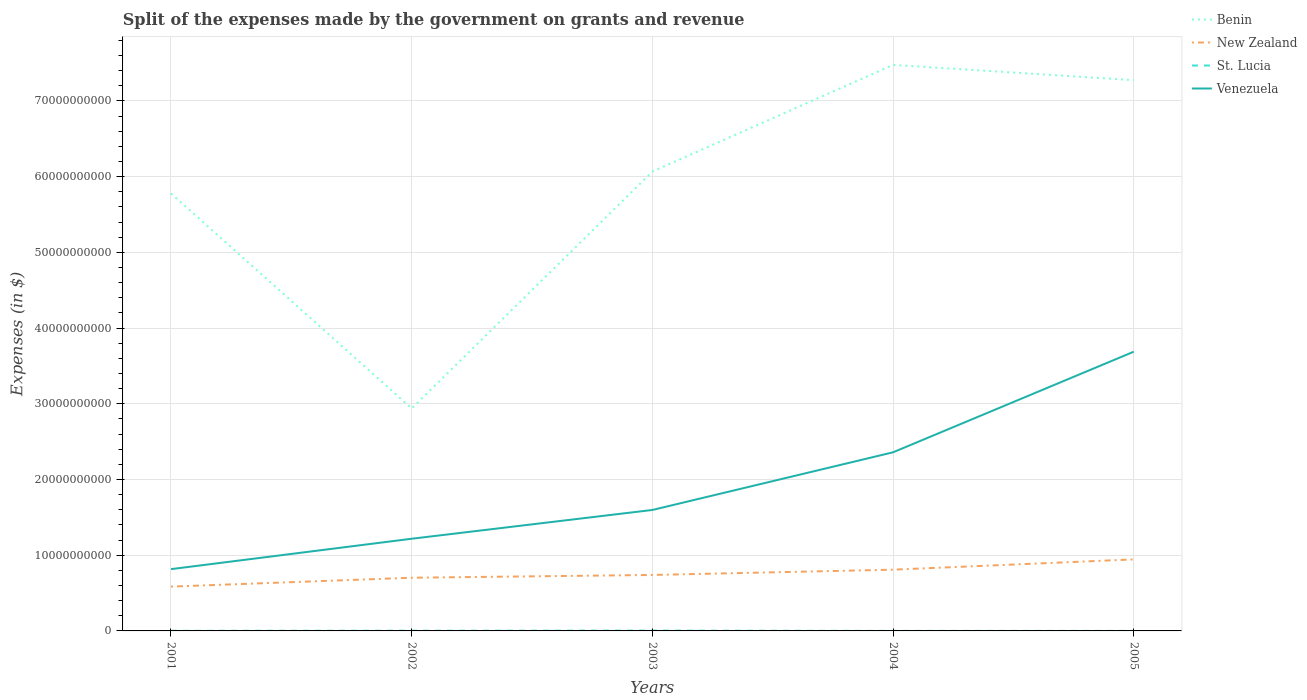How many different coloured lines are there?
Your response must be concise. 4. Does the line corresponding to St. Lucia intersect with the line corresponding to New Zealand?
Give a very brief answer. No. Is the number of lines equal to the number of legend labels?
Your answer should be compact. Yes. Across all years, what is the maximum expenses made by the government on grants and revenue in St. Lucia?
Keep it short and to the point. 4.20e+06. What is the total expenses made by the government on grants and revenue in Benin in the graph?
Provide a short and direct response. -1.21e+1. What is the difference between the highest and the second highest expenses made by the government on grants and revenue in Venezuela?
Your answer should be very brief. 2.87e+1. Is the expenses made by the government on grants and revenue in St. Lucia strictly greater than the expenses made by the government on grants and revenue in Benin over the years?
Keep it short and to the point. Yes. How many lines are there?
Keep it short and to the point. 4. How many years are there in the graph?
Your answer should be very brief. 5. What is the difference between two consecutive major ticks on the Y-axis?
Your answer should be compact. 1.00e+1. Does the graph contain any zero values?
Your answer should be very brief. No. Where does the legend appear in the graph?
Offer a very short reply. Top right. How are the legend labels stacked?
Provide a short and direct response. Vertical. What is the title of the graph?
Your answer should be compact. Split of the expenses made by the government on grants and revenue. What is the label or title of the Y-axis?
Offer a terse response. Expenses (in $). What is the Expenses (in $) of Benin in 2001?
Ensure brevity in your answer.  5.78e+1. What is the Expenses (in $) of New Zealand in 2001?
Your response must be concise. 5.85e+09. What is the Expenses (in $) in St. Lucia in 2001?
Your answer should be very brief. 1.75e+07. What is the Expenses (in $) of Venezuela in 2001?
Ensure brevity in your answer.  8.16e+09. What is the Expenses (in $) in Benin in 2002?
Offer a terse response. 2.94e+1. What is the Expenses (in $) of New Zealand in 2002?
Make the answer very short. 7.03e+09. What is the Expenses (in $) in St. Lucia in 2002?
Offer a terse response. 2.90e+07. What is the Expenses (in $) of Venezuela in 2002?
Make the answer very short. 1.22e+1. What is the Expenses (in $) in Benin in 2003?
Ensure brevity in your answer.  6.07e+1. What is the Expenses (in $) in New Zealand in 2003?
Ensure brevity in your answer.  7.39e+09. What is the Expenses (in $) in St. Lucia in 2003?
Make the answer very short. 4.30e+07. What is the Expenses (in $) of Venezuela in 2003?
Give a very brief answer. 1.60e+1. What is the Expenses (in $) of Benin in 2004?
Make the answer very short. 7.48e+1. What is the Expenses (in $) in New Zealand in 2004?
Your answer should be very brief. 8.09e+09. What is the Expenses (in $) of St. Lucia in 2004?
Make the answer very short. 6.00e+06. What is the Expenses (in $) in Venezuela in 2004?
Make the answer very short. 2.36e+1. What is the Expenses (in $) of Benin in 2005?
Your answer should be very brief. 7.27e+1. What is the Expenses (in $) in New Zealand in 2005?
Keep it short and to the point. 9.45e+09. What is the Expenses (in $) in St. Lucia in 2005?
Offer a terse response. 4.20e+06. What is the Expenses (in $) of Venezuela in 2005?
Provide a short and direct response. 3.69e+1. Across all years, what is the maximum Expenses (in $) in Benin?
Offer a very short reply. 7.48e+1. Across all years, what is the maximum Expenses (in $) of New Zealand?
Offer a terse response. 9.45e+09. Across all years, what is the maximum Expenses (in $) in St. Lucia?
Your answer should be very brief. 4.30e+07. Across all years, what is the maximum Expenses (in $) in Venezuela?
Provide a short and direct response. 3.69e+1. Across all years, what is the minimum Expenses (in $) of Benin?
Make the answer very short. 2.94e+1. Across all years, what is the minimum Expenses (in $) in New Zealand?
Offer a terse response. 5.85e+09. Across all years, what is the minimum Expenses (in $) in St. Lucia?
Provide a short and direct response. 4.20e+06. Across all years, what is the minimum Expenses (in $) in Venezuela?
Keep it short and to the point. 8.16e+09. What is the total Expenses (in $) of Benin in the graph?
Provide a succinct answer. 2.95e+11. What is the total Expenses (in $) of New Zealand in the graph?
Give a very brief answer. 3.78e+1. What is the total Expenses (in $) of St. Lucia in the graph?
Keep it short and to the point. 9.97e+07. What is the total Expenses (in $) of Venezuela in the graph?
Your response must be concise. 9.68e+1. What is the difference between the Expenses (in $) of Benin in 2001 and that in 2002?
Keep it short and to the point. 2.84e+1. What is the difference between the Expenses (in $) of New Zealand in 2001 and that in 2002?
Your answer should be very brief. -1.17e+09. What is the difference between the Expenses (in $) of St. Lucia in 2001 and that in 2002?
Provide a short and direct response. -1.15e+07. What is the difference between the Expenses (in $) of Venezuela in 2001 and that in 2002?
Ensure brevity in your answer.  -4.01e+09. What is the difference between the Expenses (in $) of Benin in 2001 and that in 2003?
Offer a terse response. -2.89e+09. What is the difference between the Expenses (in $) in New Zealand in 2001 and that in 2003?
Your answer should be compact. -1.54e+09. What is the difference between the Expenses (in $) of St. Lucia in 2001 and that in 2003?
Keep it short and to the point. -2.55e+07. What is the difference between the Expenses (in $) of Venezuela in 2001 and that in 2003?
Give a very brief answer. -7.81e+09. What is the difference between the Expenses (in $) in Benin in 2001 and that in 2004?
Your response must be concise. -1.70e+1. What is the difference between the Expenses (in $) in New Zealand in 2001 and that in 2004?
Your response must be concise. -2.23e+09. What is the difference between the Expenses (in $) of St. Lucia in 2001 and that in 2004?
Give a very brief answer. 1.15e+07. What is the difference between the Expenses (in $) in Venezuela in 2001 and that in 2004?
Provide a short and direct response. -1.54e+1. What is the difference between the Expenses (in $) in Benin in 2001 and that in 2005?
Offer a terse response. -1.50e+1. What is the difference between the Expenses (in $) in New Zealand in 2001 and that in 2005?
Keep it short and to the point. -3.59e+09. What is the difference between the Expenses (in $) in St. Lucia in 2001 and that in 2005?
Provide a short and direct response. 1.33e+07. What is the difference between the Expenses (in $) in Venezuela in 2001 and that in 2005?
Your answer should be compact. -2.87e+1. What is the difference between the Expenses (in $) of Benin in 2002 and that in 2003?
Your answer should be compact. -3.13e+1. What is the difference between the Expenses (in $) of New Zealand in 2002 and that in 2003?
Provide a succinct answer. -3.64e+08. What is the difference between the Expenses (in $) of St. Lucia in 2002 and that in 2003?
Offer a terse response. -1.40e+07. What is the difference between the Expenses (in $) of Venezuela in 2002 and that in 2003?
Your answer should be compact. -3.80e+09. What is the difference between the Expenses (in $) in Benin in 2002 and that in 2004?
Ensure brevity in your answer.  -4.54e+1. What is the difference between the Expenses (in $) of New Zealand in 2002 and that in 2004?
Your answer should be compact. -1.06e+09. What is the difference between the Expenses (in $) in St. Lucia in 2002 and that in 2004?
Offer a very short reply. 2.30e+07. What is the difference between the Expenses (in $) in Venezuela in 2002 and that in 2004?
Provide a succinct answer. -1.14e+1. What is the difference between the Expenses (in $) of Benin in 2002 and that in 2005?
Provide a short and direct response. -4.34e+1. What is the difference between the Expenses (in $) in New Zealand in 2002 and that in 2005?
Offer a very short reply. -2.42e+09. What is the difference between the Expenses (in $) of St. Lucia in 2002 and that in 2005?
Ensure brevity in your answer.  2.48e+07. What is the difference between the Expenses (in $) of Venezuela in 2002 and that in 2005?
Your answer should be very brief. -2.47e+1. What is the difference between the Expenses (in $) of Benin in 2003 and that in 2004?
Offer a terse response. -1.41e+1. What is the difference between the Expenses (in $) in New Zealand in 2003 and that in 2004?
Provide a short and direct response. -6.97e+08. What is the difference between the Expenses (in $) of St. Lucia in 2003 and that in 2004?
Your response must be concise. 3.70e+07. What is the difference between the Expenses (in $) of Venezuela in 2003 and that in 2004?
Make the answer very short. -7.62e+09. What is the difference between the Expenses (in $) of Benin in 2003 and that in 2005?
Offer a very short reply. -1.21e+1. What is the difference between the Expenses (in $) in New Zealand in 2003 and that in 2005?
Provide a short and direct response. -2.06e+09. What is the difference between the Expenses (in $) in St. Lucia in 2003 and that in 2005?
Provide a short and direct response. 3.88e+07. What is the difference between the Expenses (in $) of Venezuela in 2003 and that in 2005?
Keep it short and to the point. -2.09e+1. What is the difference between the Expenses (in $) of Benin in 2004 and that in 2005?
Keep it short and to the point. 2.02e+09. What is the difference between the Expenses (in $) in New Zealand in 2004 and that in 2005?
Make the answer very short. -1.36e+09. What is the difference between the Expenses (in $) of St. Lucia in 2004 and that in 2005?
Make the answer very short. 1.80e+06. What is the difference between the Expenses (in $) of Venezuela in 2004 and that in 2005?
Make the answer very short. -1.33e+1. What is the difference between the Expenses (in $) in Benin in 2001 and the Expenses (in $) in New Zealand in 2002?
Your response must be concise. 5.07e+1. What is the difference between the Expenses (in $) of Benin in 2001 and the Expenses (in $) of St. Lucia in 2002?
Provide a short and direct response. 5.77e+1. What is the difference between the Expenses (in $) of Benin in 2001 and the Expenses (in $) of Venezuela in 2002?
Your answer should be very brief. 4.56e+1. What is the difference between the Expenses (in $) in New Zealand in 2001 and the Expenses (in $) in St. Lucia in 2002?
Make the answer very short. 5.82e+09. What is the difference between the Expenses (in $) of New Zealand in 2001 and the Expenses (in $) of Venezuela in 2002?
Make the answer very short. -6.32e+09. What is the difference between the Expenses (in $) of St. Lucia in 2001 and the Expenses (in $) of Venezuela in 2002?
Offer a terse response. -1.22e+1. What is the difference between the Expenses (in $) of Benin in 2001 and the Expenses (in $) of New Zealand in 2003?
Your answer should be very brief. 5.04e+1. What is the difference between the Expenses (in $) of Benin in 2001 and the Expenses (in $) of St. Lucia in 2003?
Ensure brevity in your answer.  5.77e+1. What is the difference between the Expenses (in $) in Benin in 2001 and the Expenses (in $) in Venezuela in 2003?
Your response must be concise. 4.18e+1. What is the difference between the Expenses (in $) in New Zealand in 2001 and the Expenses (in $) in St. Lucia in 2003?
Your answer should be compact. 5.81e+09. What is the difference between the Expenses (in $) of New Zealand in 2001 and the Expenses (in $) of Venezuela in 2003?
Give a very brief answer. -1.01e+1. What is the difference between the Expenses (in $) in St. Lucia in 2001 and the Expenses (in $) in Venezuela in 2003?
Your answer should be compact. -1.60e+1. What is the difference between the Expenses (in $) of Benin in 2001 and the Expenses (in $) of New Zealand in 2004?
Provide a short and direct response. 4.97e+1. What is the difference between the Expenses (in $) in Benin in 2001 and the Expenses (in $) in St. Lucia in 2004?
Provide a short and direct response. 5.78e+1. What is the difference between the Expenses (in $) of Benin in 2001 and the Expenses (in $) of Venezuela in 2004?
Provide a succinct answer. 3.42e+1. What is the difference between the Expenses (in $) of New Zealand in 2001 and the Expenses (in $) of St. Lucia in 2004?
Offer a terse response. 5.85e+09. What is the difference between the Expenses (in $) in New Zealand in 2001 and the Expenses (in $) in Venezuela in 2004?
Offer a terse response. -1.77e+1. What is the difference between the Expenses (in $) in St. Lucia in 2001 and the Expenses (in $) in Venezuela in 2004?
Your response must be concise. -2.36e+1. What is the difference between the Expenses (in $) in Benin in 2001 and the Expenses (in $) in New Zealand in 2005?
Your answer should be compact. 4.83e+1. What is the difference between the Expenses (in $) in Benin in 2001 and the Expenses (in $) in St. Lucia in 2005?
Provide a short and direct response. 5.78e+1. What is the difference between the Expenses (in $) in Benin in 2001 and the Expenses (in $) in Venezuela in 2005?
Offer a very short reply. 2.09e+1. What is the difference between the Expenses (in $) of New Zealand in 2001 and the Expenses (in $) of St. Lucia in 2005?
Your answer should be very brief. 5.85e+09. What is the difference between the Expenses (in $) in New Zealand in 2001 and the Expenses (in $) in Venezuela in 2005?
Make the answer very short. -3.10e+1. What is the difference between the Expenses (in $) of St. Lucia in 2001 and the Expenses (in $) of Venezuela in 2005?
Ensure brevity in your answer.  -3.69e+1. What is the difference between the Expenses (in $) in Benin in 2002 and the Expenses (in $) in New Zealand in 2003?
Keep it short and to the point. 2.20e+1. What is the difference between the Expenses (in $) in Benin in 2002 and the Expenses (in $) in St. Lucia in 2003?
Offer a terse response. 2.93e+1. What is the difference between the Expenses (in $) of Benin in 2002 and the Expenses (in $) of Venezuela in 2003?
Make the answer very short. 1.34e+1. What is the difference between the Expenses (in $) in New Zealand in 2002 and the Expenses (in $) in St. Lucia in 2003?
Make the answer very short. 6.98e+09. What is the difference between the Expenses (in $) in New Zealand in 2002 and the Expenses (in $) in Venezuela in 2003?
Your answer should be compact. -8.95e+09. What is the difference between the Expenses (in $) of St. Lucia in 2002 and the Expenses (in $) of Venezuela in 2003?
Keep it short and to the point. -1.59e+1. What is the difference between the Expenses (in $) of Benin in 2002 and the Expenses (in $) of New Zealand in 2004?
Offer a very short reply. 2.13e+1. What is the difference between the Expenses (in $) in Benin in 2002 and the Expenses (in $) in St. Lucia in 2004?
Your answer should be very brief. 2.94e+1. What is the difference between the Expenses (in $) in Benin in 2002 and the Expenses (in $) in Venezuela in 2004?
Your response must be concise. 5.79e+09. What is the difference between the Expenses (in $) of New Zealand in 2002 and the Expenses (in $) of St. Lucia in 2004?
Give a very brief answer. 7.02e+09. What is the difference between the Expenses (in $) of New Zealand in 2002 and the Expenses (in $) of Venezuela in 2004?
Your answer should be compact. -1.66e+1. What is the difference between the Expenses (in $) of St. Lucia in 2002 and the Expenses (in $) of Venezuela in 2004?
Offer a very short reply. -2.36e+1. What is the difference between the Expenses (in $) of Benin in 2002 and the Expenses (in $) of New Zealand in 2005?
Provide a succinct answer. 1.99e+1. What is the difference between the Expenses (in $) in Benin in 2002 and the Expenses (in $) in St. Lucia in 2005?
Your answer should be compact. 2.94e+1. What is the difference between the Expenses (in $) in Benin in 2002 and the Expenses (in $) in Venezuela in 2005?
Your response must be concise. -7.49e+09. What is the difference between the Expenses (in $) of New Zealand in 2002 and the Expenses (in $) of St. Lucia in 2005?
Make the answer very short. 7.02e+09. What is the difference between the Expenses (in $) in New Zealand in 2002 and the Expenses (in $) in Venezuela in 2005?
Keep it short and to the point. -2.99e+1. What is the difference between the Expenses (in $) in St. Lucia in 2002 and the Expenses (in $) in Venezuela in 2005?
Offer a terse response. -3.68e+1. What is the difference between the Expenses (in $) of Benin in 2003 and the Expenses (in $) of New Zealand in 2004?
Make the answer very short. 5.26e+1. What is the difference between the Expenses (in $) in Benin in 2003 and the Expenses (in $) in St. Lucia in 2004?
Your answer should be compact. 6.07e+1. What is the difference between the Expenses (in $) in Benin in 2003 and the Expenses (in $) in Venezuela in 2004?
Your answer should be very brief. 3.71e+1. What is the difference between the Expenses (in $) in New Zealand in 2003 and the Expenses (in $) in St. Lucia in 2004?
Make the answer very short. 7.38e+09. What is the difference between the Expenses (in $) in New Zealand in 2003 and the Expenses (in $) in Venezuela in 2004?
Your response must be concise. -1.62e+1. What is the difference between the Expenses (in $) in St. Lucia in 2003 and the Expenses (in $) in Venezuela in 2004?
Provide a short and direct response. -2.35e+1. What is the difference between the Expenses (in $) in Benin in 2003 and the Expenses (in $) in New Zealand in 2005?
Your response must be concise. 5.12e+1. What is the difference between the Expenses (in $) in Benin in 2003 and the Expenses (in $) in St. Lucia in 2005?
Your response must be concise. 6.07e+1. What is the difference between the Expenses (in $) of Benin in 2003 and the Expenses (in $) of Venezuela in 2005?
Your answer should be very brief. 2.38e+1. What is the difference between the Expenses (in $) of New Zealand in 2003 and the Expenses (in $) of St. Lucia in 2005?
Your answer should be very brief. 7.39e+09. What is the difference between the Expenses (in $) of New Zealand in 2003 and the Expenses (in $) of Venezuela in 2005?
Provide a short and direct response. -2.95e+1. What is the difference between the Expenses (in $) in St. Lucia in 2003 and the Expenses (in $) in Venezuela in 2005?
Provide a short and direct response. -3.68e+1. What is the difference between the Expenses (in $) in Benin in 2004 and the Expenses (in $) in New Zealand in 2005?
Make the answer very short. 6.53e+1. What is the difference between the Expenses (in $) of Benin in 2004 and the Expenses (in $) of St. Lucia in 2005?
Provide a succinct answer. 7.48e+1. What is the difference between the Expenses (in $) of Benin in 2004 and the Expenses (in $) of Venezuela in 2005?
Give a very brief answer. 3.79e+1. What is the difference between the Expenses (in $) of New Zealand in 2004 and the Expenses (in $) of St. Lucia in 2005?
Make the answer very short. 8.08e+09. What is the difference between the Expenses (in $) in New Zealand in 2004 and the Expenses (in $) in Venezuela in 2005?
Make the answer very short. -2.88e+1. What is the difference between the Expenses (in $) of St. Lucia in 2004 and the Expenses (in $) of Venezuela in 2005?
Provide a short and direct response. -3.69e+1. What is the average Expenses (in $) of Benin per year?
Your answer should be compact. 5.91e+1. What is the average Expenses (in $) of New Zealand per year?
Keep it short and to the point. 7.56e+09. What is the average Expenses (in $) in St. Lucia per year?
Ensure brevity in your answer.  1.99e+07. What is the average Expenses (in $) of Venezuela per year?
Make the answer very short. 1.94e+1. In the year 2001, what is the difference between the Expenses (in $) of Benin and Expenses (in $) of New Zealand?
Offer a terse response. 5.19e+1. In the year 2001, what is the difference between the Expenses (in $) of Benin and Expenses (in $) of St. Lucia?
Provide a short and direct response. 5.78e+1. In the year 2001, what is the difference between the Expenses (in $) of Benin and Expenses (in $) of Venezuela?
Provide a succinct answer. 4.96e+1. In the year 2001, what is the difference between the Expenses (in $) in New Zealand and Expenses (in $) in St. Lucia?
Keep it short and to the point. 5.84e+09. In the year 2001, what is the difference between the Expenses (in $) in New Zealand and Expenses (in $) in Venezuela?
Offer a very short reply. -2.31e+09. In the year 2001, what is the difference between the Expenses (in $) of St. Lucia and Expenses (in $) of Venezuela?
Ensure brevity in your answer.  -8.14e+09. In the year 2002, what is the difference between the Expenses (in $) of Benin and Expenses (in $) of New Zealand?
Offer a very short reply. 2.24e+1. In the year 2002, what is the difference between the Expenses (in $) of Benin and Expenses (in $) of St. Lucia?
Your answer should be compact. 2.94e+1. In the year 2002, what is the difference between the Expenses (in $) of Benin and Expenses (in $) of Venezuela?
Your answer should be compact. 1.72e+1. In the year 2002, what is the difference between the Expenses (in $) in New Zealand and Expenses (in $) in St. Lucia?
Provide a succinct answer. 7.00e+09. In the year 2002, what is the difference between the Expenses (in $) of New Zealand and Expenses (in $) of Venezuela?
Provide a succinct answer. -5.15e+09. In the year 2002, what is the difference between the Expenses (in $) of St. Lucia and Expenses (in $) of Venezuela?
Your answer should be compact. -1.21e+1. In the year 2003, what is the difference between the Expenses (in $) of Benin and Expenses (in $) of New Zealand?
Your answer should be compact. 5.33e+1. In the year 2003, what is the difference between the Expenses (in $) of Benin and Expenses (in $) of St. Lucia?
Give a very brief answer. 6.06e+1. In the year 2003, what is the difference between the Expenses (in $) in Benin and Expenses (in $) in Venezuela?
Make the answer very short. 4.47e+1. In the year 2003, what is the difference between the Expenses (in $) in New Zealand and Expenses (in $) in St. Lucia?
Give a very brief answer. 7.35e+09. In the year 2003, what is the difference between the Expenses (in $) in New Zealand and Expenses (in $) in Venezuela?
Your answer should be compact. -8.58e+09. In the year 2003, what is the difference between the Expenses (in $) of St. Lucia and Expenses (in $) of Venezuela?
Provide a short and direct response. -1.59e+1. In the year 2004, what is the difference between the Expenses (in $) in Benin and Expenses (in $) in New Zealand?
Make the answer very short. 6.67e+1. In the year 2004, what is the difference between the Expenses (in $) in Benin and Expenses (in $) in St. Lucia?
Your response must be concise. 7.47e+1. In the year 2004, what is the difference between the Expenses (in $) of Benin and Expenses (in $) of Venezuela?
Provide a succinct answer. 5.12e+1. In the year 2004, what is the difference between the Expenses (in $) of New Zealand and Expenses (in $) of St. Lucia?
Your answer should be very brief. 8.08e+09. In the year 2004, what is the difference between the Expenses (in $) in New Zealand and Expenses (in $) in Venezuela?
Ensure brevity in your answer.  -1.55e+1. In the year 2004, what is the difference between the Expenses (in $) of St. Lucia and Expenses (in $) of Venezuela?
Make the answer very short. -2.36e+1. In the year 2005, what is the difference between the Expenses (in $) in Benin and Expenses (in $) in New Zealand?
Provide a short and direct response. 6.33e+1. In the year 2005, what is the difference between the Expenses (in $) of Benin and Expenses (in $) of St. Lucia?
Give a very brief answer. 7.27e+1. In the year 2005, what is the difference between the Expenses (in $) in Benin and Expenses (in $) in Venezuela?
Give a very brief answer. 3.59e+1. In the year 2005, what is the difference between the Expenses (in $) of New Zealand and Expenses (in $) of St. Lucia?
Make the answer very short. 9.44e+09. In the year 2005, what is the difference between the Expenses (in $) in New Zealand and Expenses (in $) in Venezuela?
Your answer should be very brief. -2.74e+1. In the year 2005, what is the difference between the Expenses (in $) of St. Lucia and Expenses (in $) of Venezuela?
Your answer should be very brief. -3.69e+1. What is the ratio of the Expenses (in $) in Benin in 2001 to that in 2002?
Make the answer very short. 1.97. What is the ratio of the Expenses (in $) of New Zealand in 2001 to that in 2002?
Your answer should be very brief. 0.83. What is the ratio of the Expenses (in $) in St. Lucia in 2001 to that in 2002?
Your answer should be compact. 0.6. What is the ratio of the Expenses (in $) of Venezuela in 2001 to that in 2002?
Your answer should be compact. 0.67. What is the ratio of the Expenses (in $) in Benin in 2001 to that in 2003?
Your answer should be compact. 0.95. What is the ratio of the Expenses (in $) of New Zealand in 2001 to that in 2003?
Give a very brief answer. 0.79. What is the ratio of the Expenses (in $) in St. Lucia in 2001 to that in 2003?
Offer a very short reply. 0.41. What is the ratio of the Expenses (in $) in Venezuela in 2001 to that in 2003?
Provide a succinct answer. 0.51. What is the ratio of the Expenses (in $) of Benin in 2001 to that in 2004?
Your answer should be compact. 0.77. What is the ratio of the Expenses (in $) of New Zealand in 2001 to that in 2004?
Provide a short and direct response. 0.72. What is the ratio of the Expenses (in $) in St. Lucia in 2001 to that in 2004?
Make the answer very short. 2.92. What is the ratio of the Expenses (in $) of Venezuela in 2001 to that in 2004?
Keep it short and to the point. 0.35. What is the ratio of the Expenses (in $) in Benin in 2001 to that in 2005?
Give a very brief answer. 0.79. What is the ratio of the Expenses (in $) of New Zealand in 2001 to that in 2005?
Make the answer very short. 0.62. What is the ratio of the Expenses (in $) in St. Lucia in 2001 to that in 2005?
Offer a very short reply. 4.17. What is the ratio of the Expenses (in $) in Venezuela in 2001 to that in 2005?
Your answer should be very brief. 0.22. What is the ratio of the Expenses (in $) in Benin in 2002 to that in 2003?
Offer a very short reply. 0.48. What is the ratio of the Expenses (in $) in New Zealand in 2002 to that in 2003?
Keep it short and to the point. 0.95. What is the ratio of the Expenses (in $) in St. Lucia in 2002 to that in 2003?
Your answer should be very brief. 0.67. What is the ratio of the Expenses (in $) in Venezuela in 2002 to that in 2003?
Ensure brevity in your answer.  0.76. What is the ratio of the Expenses (in $) in Benin in 2002 to that in 2004?
Keep it short and to the point. 0.39. What is the ratio of the Expenses (in $) of New Zealand in 2002 to that in 2004?
Offer a terse response. 0.87. What is the ratio of the Expenses (in $) in St. Lucia in 2002 to that in 2004?
Keep it short and to the point. 4.83. What is the ratio of the Expenses (in $) in Venezuela in 2002 to that in 2004?
Make the answer very short. 0.52. What is the ratio of the Expenses (in $) in Benin in 2002 to that in 2005?
Ensure brevity in your answer.  0.4. What is the ratio of the Expenses (in $) in New Zealand in 2002 to that in 2005?
Provide a short and direct response. 0.74. What is the ratio of the Expenses (in $) in St. Lucia in 2002 to that in 2005?
Keep it short and to the point. 6.9. What is the ratio of the Expenses (in $) in Venezuela in 2002 to that in 2005?
Your response must be concise. 0.33. What is the ratio of the Expenses (in $) in Benin in 2003 to that in 2004?
Offer a very short reply. 0.81. What is the ratio of the Expenses (in $) of New Zealand in 2003 to that in 2004?
Give a very brief answer. 0.91. What is the ratio of the Expenses (in $) in St. Lucia in 2003 to that in 2004?
Offer a terse response. 7.17. What is the ratio of the Expenses (in $) of Venezuela in 2003 to that in 2004?
Give a very brief answer. 0.68. What is the ratio of the Expenses (in $) of Benin in 2003 to that in 2005?
Provide a succinct answer. 0.83. What is the ratio of the Expenses (in $) of New Zealand in 2003 to that in 2005?
Make the answer very short. 0.78. What is the ratio of the Expenses (in $) in St. Lucia in 2003 to that in 2005?
Your response must be concise. 10.24. What is the ratio of the Expenses (in $) in Venezuela in 2003 to that in 2005?
Make the answer very short. 0.43. What is the ratio of the Expenses (in $) in Benin in 2004 to that in 2005?
Make the answer very short. 1.03. What is the ratio of the Expenses (in $) of New Zealand in 2004 to that in 2005?
Offer a very short reply. 0.86. What is the ratio of the Expenses (in $) of St. Lucia in 2004 to that in 2005?
Make the answer very short. 1.43. What is the ratio of the Expenses (in $) of Venezuela in 2004 to that in 2005?
Ensure brevity in your answer.  0.64. What is the difference between the highest and the second highest Expenses (in $) of Benin?
Your response must be concise. 2.02e+09. What is the difference between the highest and the second highest Expenses (in $) in New Zealand?
Keep it short and to the point. 1.36e+09. What is the difference between the highest and the second highest Expenses (in $) in St. Lucia?
Your answer should be compact. 1.40e+07. What is the difference between the highest and the second highest Expenses (in $) of Venezuela?
Ensure brevity in your answer.  1.33e+1. What is the difference between the highest and the lowest Expenses (in $) of Benin?
Provide a short and direct response. 4.54e+1. What is the difference between the highest and the lowest Expenses (in $) of New Zealand?
Provide a succinct answer. 3.59e+09. What is the difference between the highest and the lowest Expenses (in $) of St. Lucia?
Your answer should be compact. 3.88e+07. What is the difference between the highest and the lowest Expenses (in $) in Venezuela?
Your answer should be compact. 2.87e+1. 